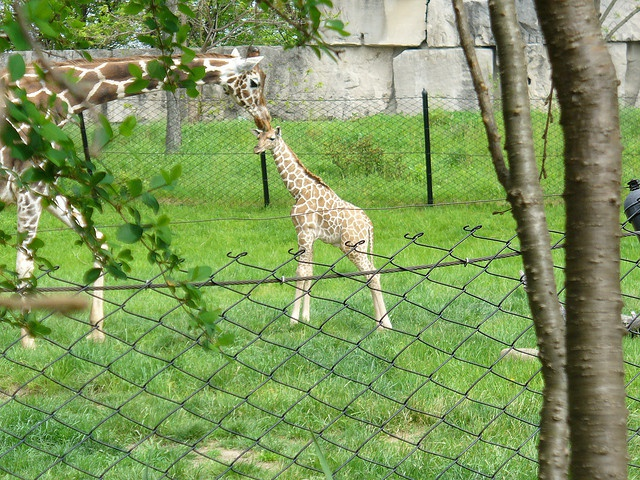Describe the objects in this image and their specific colors. I can see giraffe in gray, darkgreen, olive, and ivory tones, giraffe in gray, ivory, and tan tones, and bird in gray, black, and darkgray tones in this image. 